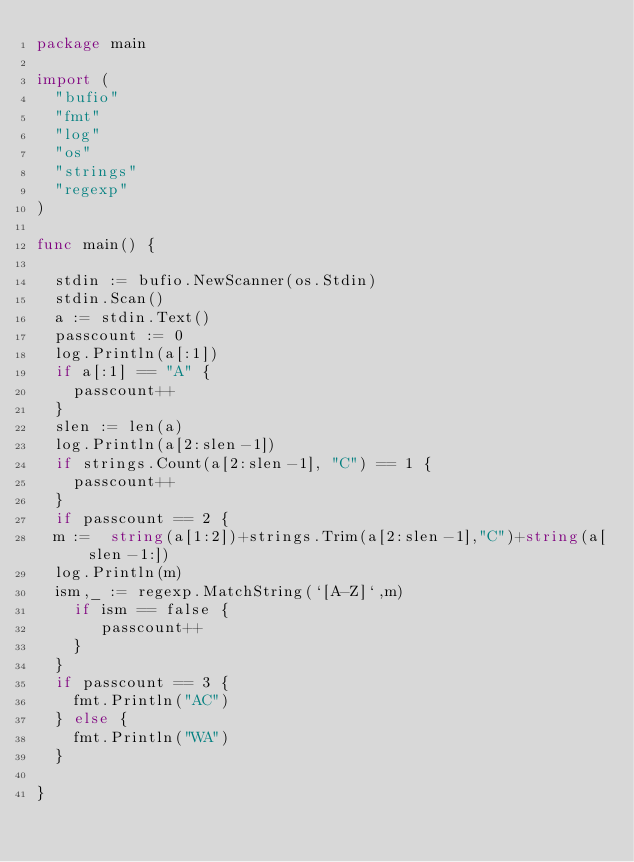<code> <loc_0><loc_0><loc_500><loc_500><_Go_>package main

import (
	"bufio"
	"fmt"
	"log"
	"os"
	"strings"
	"regexp"
)

func main() {

	stdin := bufio.NewScanner(os.Stdin)
	stdin.Scan()
	a := stdin.Text()
	passcount := 0
	log.Println(a[:1])
	if a[:1] == "A" {
		passcount++
	}
	slen := len(a)
	log.Println(a[2:slen-1])
	if strings.Count(a[2:slen-1], "C") == 1 {
		passcount++
	}
	if passcount == 2 {
	m :=	string(a[1:2])+strings.Trim(a[2:slen-1],"C")+string(a[slen-1:])
	log.Println(m)
	ism,_ := regexp.MatchString(`[A-Z]`,m)
		if ism == false {
		   passcount++
		}
	}
	if passcount == 3 {
		fmt.Println("AC")
	} else {
		fmt.Println("WA")
	}

}
</code> 